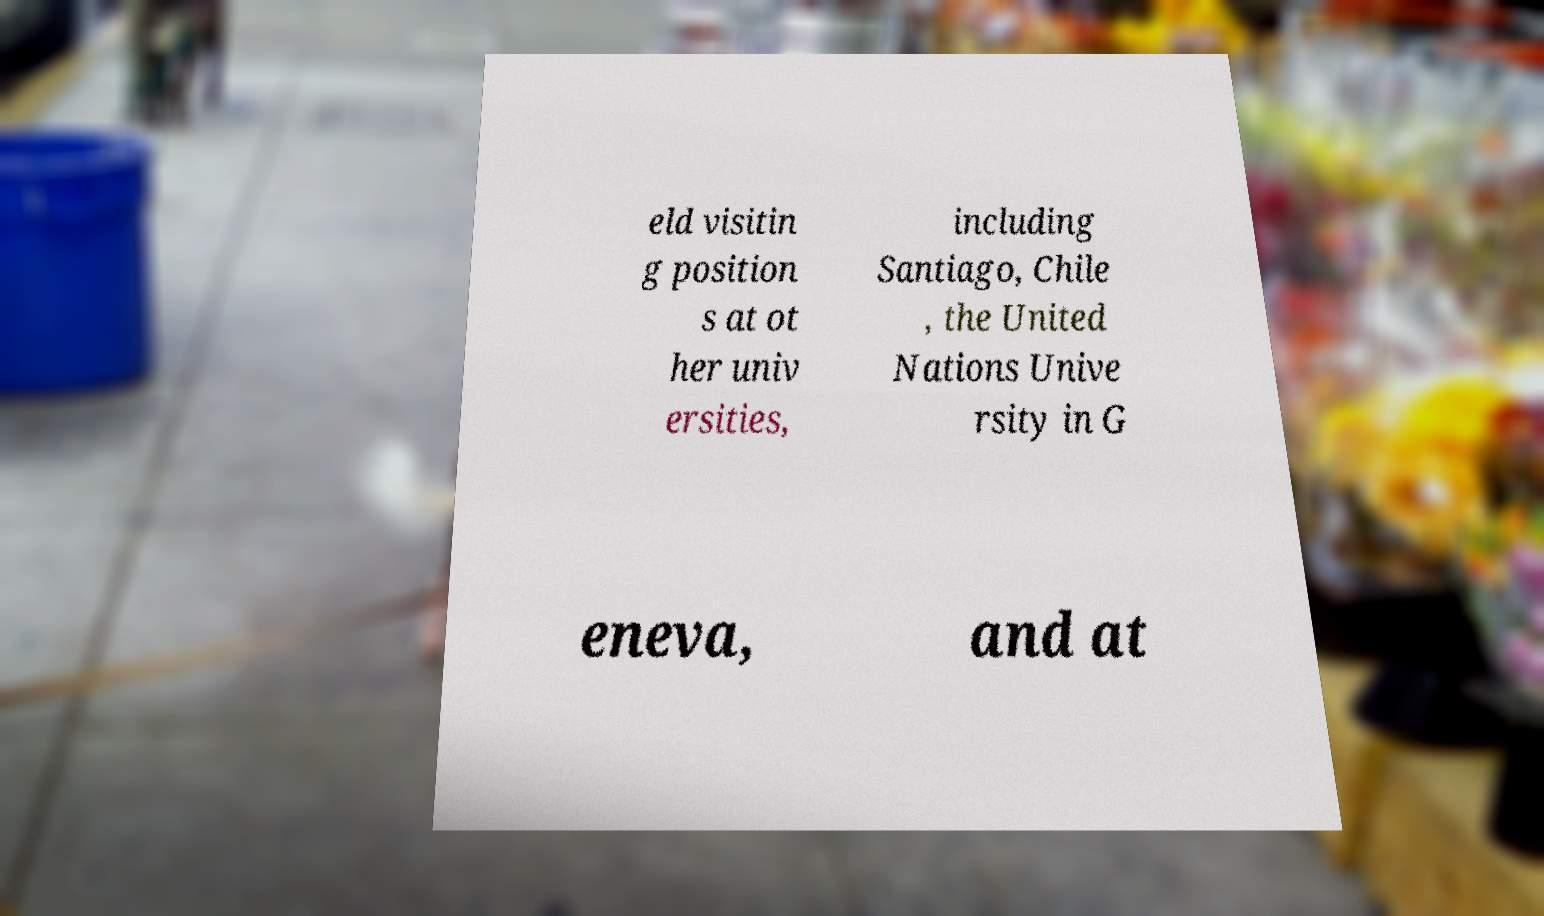Could you extract and type out the text from this image? eld visitin g position s at ot her univ ersities, including Santiago, Chile , the United Nations Unive rsity in G eneva, and at 